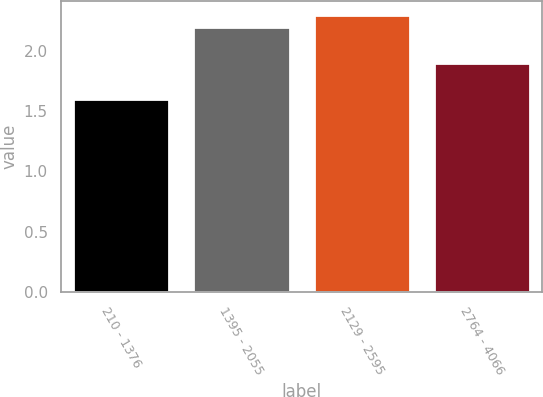Convert chart. <chart><loc_0><loc_0><loc_500><loc_500><bar_chart><fcel>210 - 1376<fcel>1395 - 2055<fcel>2129 - 2595<fcel>2764 - 4066<nl><fcel>1.6<fcel>2.2<fcel>2.3<fcel>1.9<nl></chart> 